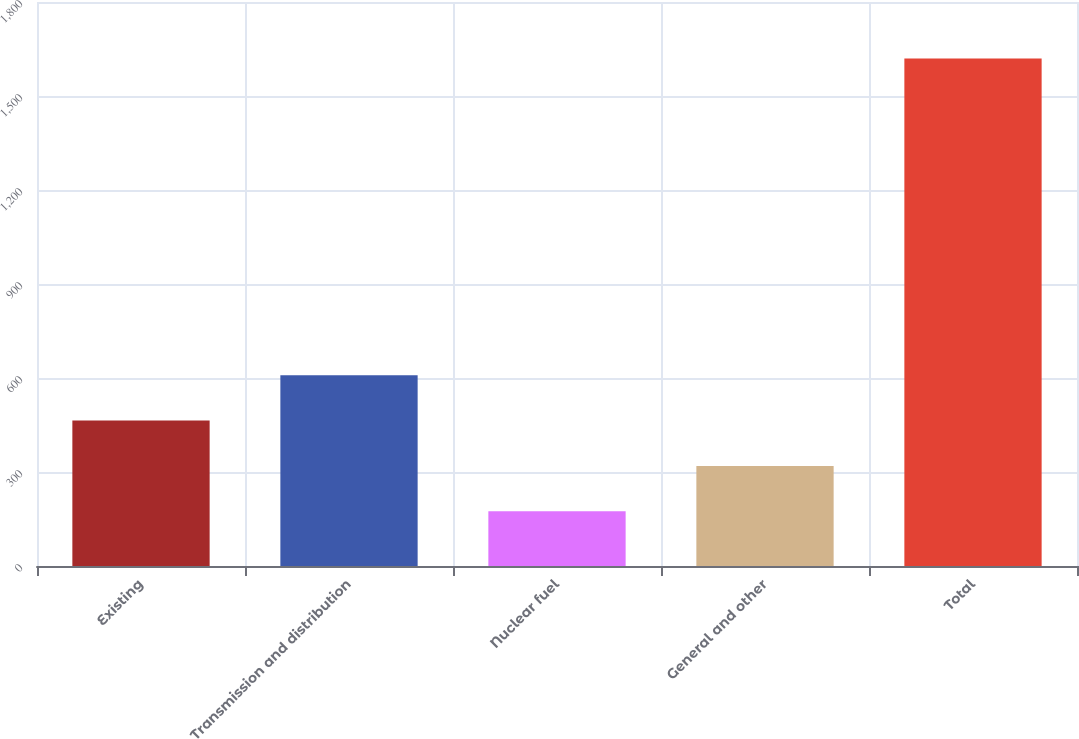<chart> <loc_0><loc_0><loc_500><loc_500><bar_chart><fcel>Existing<fcel>Transmission and distribution<fcel>Nuclear fuel<fcel>General and other<fcel>Total<nl><fcel>464<fcel>608.5<fcel>175<fcel>319.5<fcel>1620<nl></chart> 